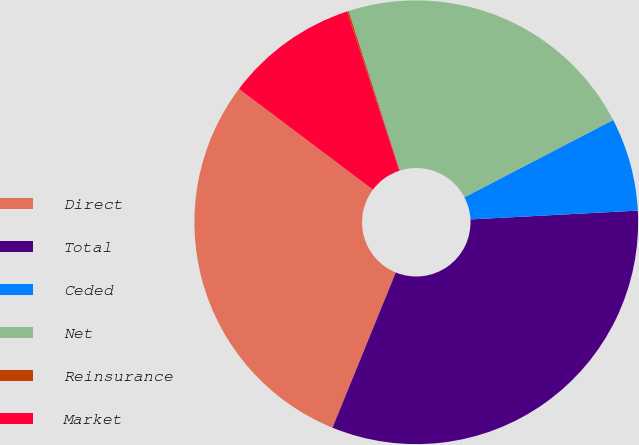Convert chart. <chart><loc_0><loc_0><loc_500><loc_500><pie_chart><fcel>Direct<fcel>Total<fcel>Ceded<fcel>Net<fcel>Reinsurance<fcel>Market<nl><fcel>29.1%<fcel>32.0%<fcel>6.79%<fcel>22.31%<fcel>0.11%<fcel>9.69%<nl></chart> 